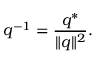Convert formula to latex. <formula><loc_0><loc_0><loc_500><loc_500>q ^ { - 1 } = { \frac { q ^ { * } } { \| q \| ^ { 2 } } } .</formula> 